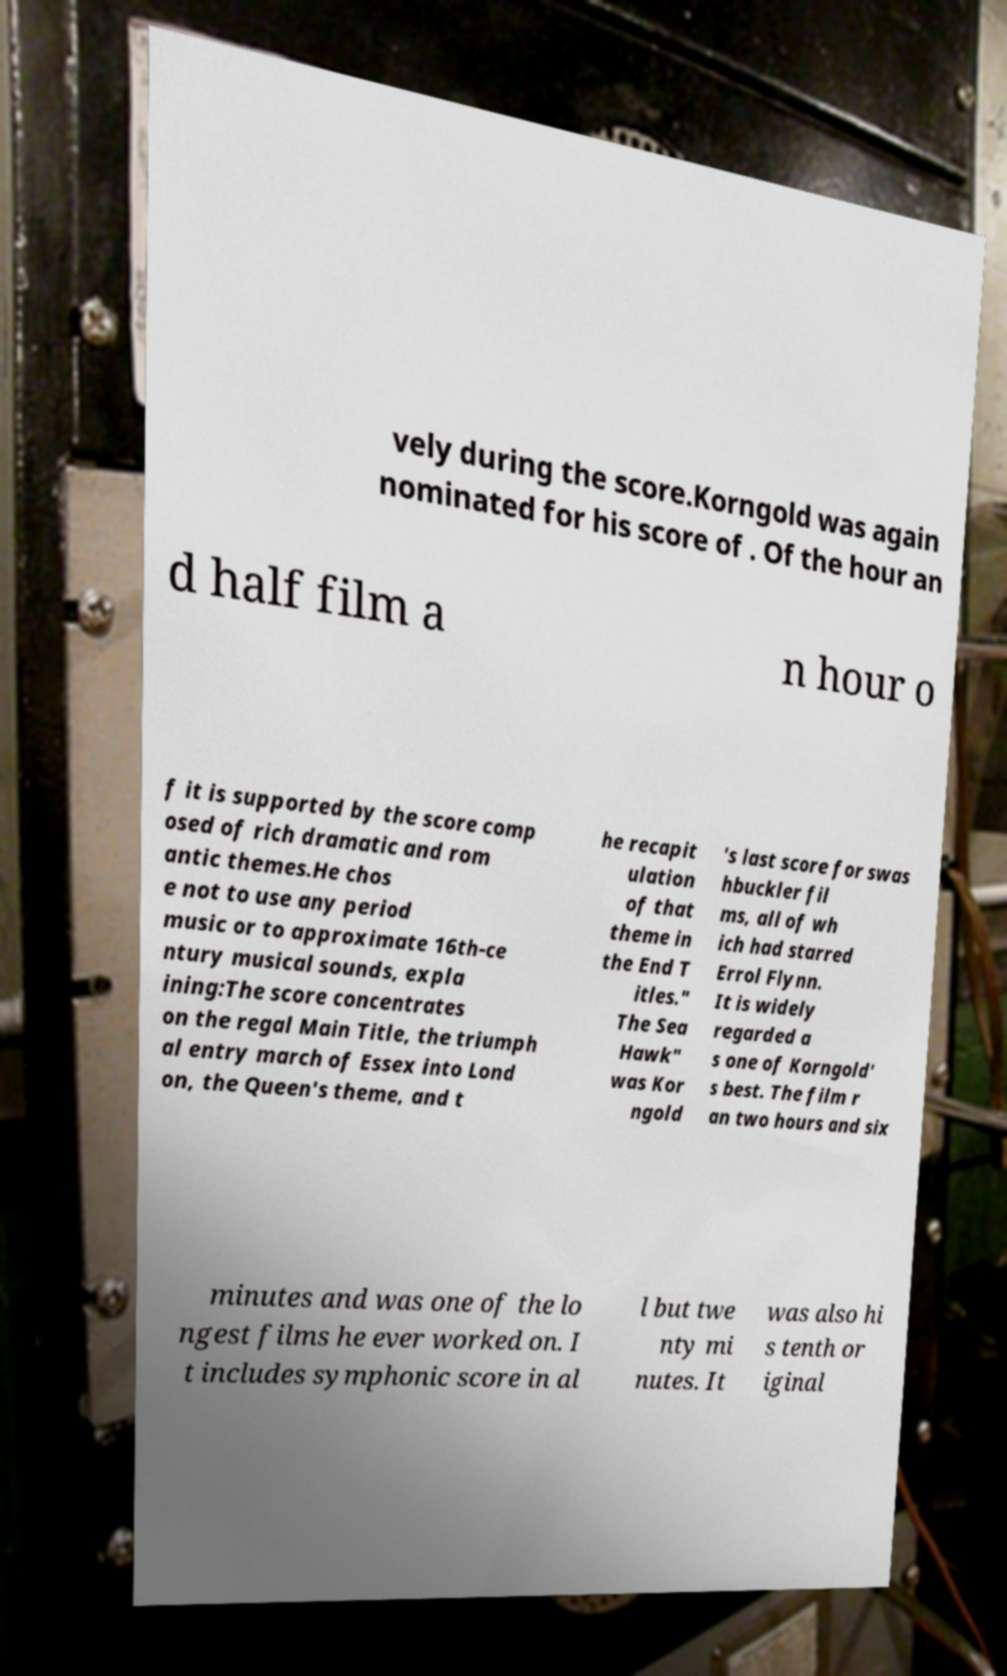What messages or text are displayed in this image? I need them in a readable, typed format. vely during the score.Korngold was again nominated for his score of . Of the hour an d half film a n hour o f it is supported by the score comp osed of rich dramatic and rom antic themes.He chos e not to use any period music or to approximate 16th-ce ntury musical sounds, expla ining:The score concentrates on the regal Main Title, the triumph al entry march of Essex into Lond on, the Queen's theme, and t he recapit ulation of that theme in the End T itles." The Sea Hawk" was Kor ngold 's last score for swas hbuckler fil ms, all of wh ich had starred Errol Flynn. It is widely regarded a s one of Korngold' s best. The film r an two hours and six minutes and was one of the lo ngest films he ever worked on. I t includes symphonic score in al l but twe nty mi nutes. It was also hi s tenth or iginal 